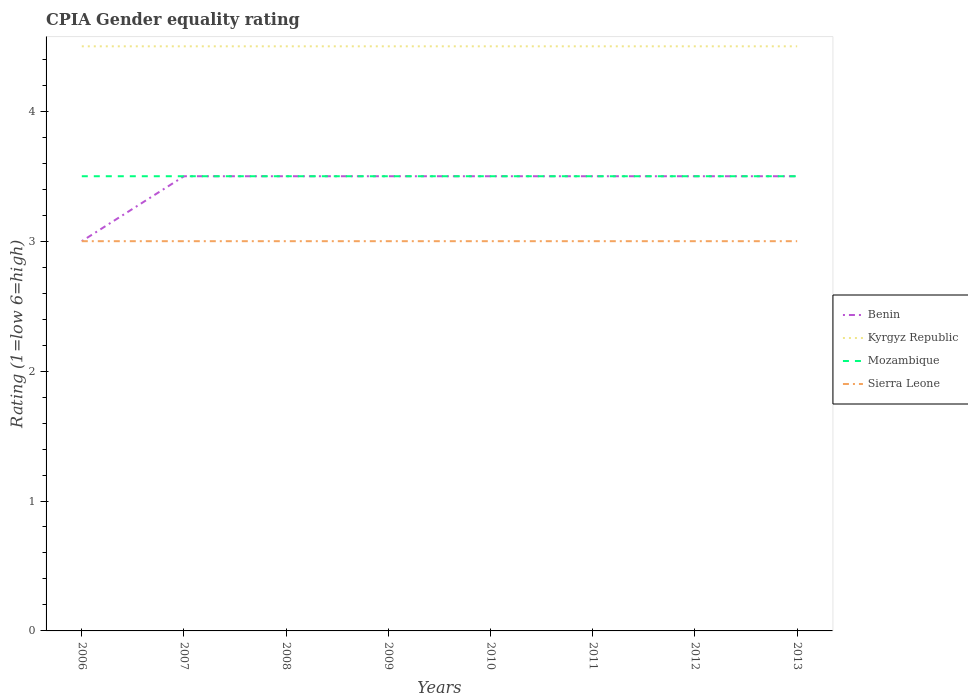Across all years, what is the maximum CPIA rating in Benin?
Ensure brevity in your answer.  3. In which year was the CPIA rating in Kyrgyz Republic maximum?
Offer a very short reply. 2006. What is the difference between the highest and the second highest CPIA rating in Kyrgyz Republic?
Provide a succinct answer. 0. What is the difference between the highest and the lowest CPIA rating in Benin?
Keep it short and to the point. 7. How many years are there in the graph?
Offer a terse response. 8. What is the difference between two consecutive major ticks on the Y-axis?
Provide a short and direct response. 1. How many legend labels are there?
Ensure brevity in your answer.  4. How are the legend labels stacked?
Ensure brevity in your answer.  Vertical. What is the title of the graph?
Provide a succinct answer. CPIA Gender equality rating. What is the label or title of the X-axis?
Your answer should be compact. Years. What is the Rating (1=low 6=high) in Benin in 2006?
Your response must be concise. 3. What is the Rating (1=low 6=high) of Sierra Leone in 2006?
Your answer should be very brief. 3. What is the Rating (1=low 6=high) in Kyrgyz Republic in 2007?
Provide a succinct answer. 4.5. What is the Rating (1=low 6=high) in Benin in 2008?
Your answer should be compact. 3.5. What is the Rating (1=low 6=high) of Benin in 2009?
Your answer should be very brief. 3.5. What is the Rating (1=low 6=high) of Kyrgyz Republic in 2009?
Give a very brief answer. 4.5. What is the Rating (1=low 6=high) in Benin in 2010?
Provide a succinct answer. 3.5. What is the Rating (1=low 6=high) of Mozambique in 2011?
Provide a succinct answer. 3.5. What is the Rating (1=low 6=high) in Sierra Leone in 2011?
Give a very brief answer. 3. What is the Rating (1=low 6=high) in Kyrgyz Republic in 2012?
Keep it short and to the point. 4.5. What is the Rating (1=low 6=high) of Kyrgyz Republic in 2013?
Your answer should be compact. 4.5. What is the Rating (1=low 6=high) in Mozambique in 2013?
Provide a succinct answer. 3.5. Across all years, what is the maximum Rating (1=low 6=high) of Benin?
Offer a terse response. 3.5. Across all years, what is the maximum Rating (1=low 6=high) in Kyrgyz Republic?
Your answer should be very brief. 4.5. Across all years, what is the maximum Rating (1=low 6=high) of Sierra Leone?
Provide a short and direct response. 3. Across all years, what is the minimum Rating (1=low 6=high) in Benin?
Your response must be concise. 3. Across all years, what is the minimum Rating (1=low 6=high) of Kyrgyz Republic?
Ensure brevity in your answer.  4.5. Across all years, what is the minimum Rating (1=low 6=high) in Sierra Leone?
Your answer should be compact. 3. What is the total Rating (1=low 6=high) of Kyrgyz Republic in the graph?
Provide a succinct answer. 36. What is the difference between the Rating (1=low 6=high) of Benin in 2006 and that in 2008?
Provide a short and direct response. -0.5. What is the difference between the Rating (1=low 6=high) of Sierra Leone in 2006 and that in 2008?
Provide a short and direct response. 0. What is the difference between the Rating (1=low 6=high) in Mozambique in 2006 and that in 2009?
Provide a short and direct response. 0. What is the difference between the Rating (1=low 6=high) in Benin in 2006 and that in 2010?
Provide a succinct answer. -0.5. What is the difference between the Rating (1=low 6=high) of Kyrgyz Republic in 2006 and that in 2010?
Provide a short and direct response. 0. What is the difference between the Rating (1=low 6=high) in Mozambique in 2006 and that in 2010?
Your response must be concise. 0. What is the difference between the Rating (1=low 6=high) of Sierra Leone in 2006 and that in 2010?
Keep it short and to the point. 0. What is the difference between the Rating (1=low 6=high) in Kyrgyz Republic in 2006 and that in 2011?
Ensure brevity in your answer.  0. What is the difference between the Rating (1=low 6=high) of Sierra Leone in 2006 and that in 2011?
Ensure brevity in your answer.  0. What is the difference between the Rating (1=low 6=high) in Benin in 2006 and that in 2012?
Make the answer very short. -0.5. What is the difference between the Rating (1=low 6=high) of Mozambique in 2006 and that in 2012?
Offer a very short reply. 0. What is the difference between the Rating (1=low 6=high) of Sierra Leone in 2006 and that in 2012?
Offer a terse response. 0. What is the difference between the Rating (1=low 6=high) of Sierra Leone in 2007 and that in 2008?
Make the answer very short. 0. What is the difference between the Rating (1=low 6=high) of Mozambique in 2007 and that in 2009?
Your response must be concise. 0. What is the difference between the Rating (1=low 6=high) in Sierra Leone in 2007 and that in 2009?
Give a very brief answer. 0. What is the difference between the Rating (1=low 6=high) in Benin in 2007 and that in 2010?
Provide a succinct answer. 0. What is the difference between the Rating (1=low 6=high) of Mozambique in 2007 and that in 2010?
Make the answer very short. 0. What is the difference between the Rating (1=low 6=high) in Sierra Leone in 2007 and that in 2010?
Keep it short and to the point. 0. What is the difference between the Rating (1=low 6=high) of Benin in 2007 and that in 2012?
Keep it short and to the point. 0. What is the difference between the Rating (1=low 6=high) of Mozambique in 2007 and that in 2012?
Provide a short and direct response. 0. What is the difference between the Rating (1=low 6=high) in Benin in 2007 and that in 2013?
Provide a succinct answer. 0. What is the difference between the Rating (1=low 6=high) in Mozambique in 2007 and that in 2013?
Make the answer very short. 0. What is the difference between the Rating (1=low 6=high) in Sierra Leone in 2007 and that in 2013?
Offer a very short reply. 0. What is the difference between the Rating (1=low 6=high) of Benin in 2008 and that in 2009?
Provide a short and direct response. 0. What is the difference between the Rating (1=low 6=high) in Kyrgyz Republic in 2008 and that in 2009?
Offer a very short reply. 0. What is the difference between the Rating (1=low 6=high) of Sierra Leone in 2008 and that in 2010?
Your answer should be very brief. 0. What is the difference between the Rating (1=low 6=high) of Benin in 2008 and that in 2011?
Your answer should be compact. 0. What is the difference between the Rating (1=low 6=high) in Mozambique in 2008 and that in 2011?
Ensure brevity in your answer.  0. What is the difference between the Rating (1=low 6=high) in Benin in 2008 and that in 2012?
Give a very brief answer. 0. What is the difference between the Rating (1=low 6=high) in Mozambique in 2008 and that in 2012?
Keep it short and to the point. 0. What is the difference between the Rating (1=low 6=high) in Benin in 2008 and that in 2013?
Ensure brevity in your answer.  0. What is the difference between the Rating (1=low 6=high) of Sierra Leone in 2008 and that in 2013?
Give a very brief answer. 0. What is the difference between the Rating (1=low 6=high) in Benin in 2009 and that in 2010?
Keep it short and to the point. 0. What is the difference between the Rating (1=low 6=high) of Kyrgyz Republic in 2009 and that in 2010?
Provide a succinct answer. 0. What is the difference between the Rating (1=low 6=high) of Kyrgyz Republic in 2009 and that in 2011?
Offer a very short reply. 0. What is the difference between the Rating (1=low 6=high) in Mozambique in 2009 and that in 2011?
Offer a terse response. 0. What is the difference between the Rating (1=low 6=high) in Sierra Leone in 2009 and that in 2011?
Make the answer very short. 0. What is the difference between the Rating (1=low 6=high) in Benin in 2009 and that in 2012?
Ensure brevity in your answer.  0. What is the difference between the Rating (1=low 6=high) in Kyrgyz Republic in 2009 and that in 2012?
Provide a short and direct response. 0. What is the difference between the Rating (1=low 6=high) in Sierra Leone in 2009 and that in 2012?
Offer a terse response. 0. What is the difference between the Rating (1=low 6=high) of Sierra Leone in 2009 and that in 2013?
Your answer should be compact. 0. What is the difference between the Rating (1=low 6=high) of Benin in 2010 and that in 2011?
Your answer should be compact. 0. What is the difference between the Rating (1=low 6=high) of Sierra Leone in 2010 and that in 2011?
Your answer should be compact. 0. What is the difference between the Rating (1=low 6=high) in Benin in 2010 and that in 2012?
Your answer should be compact. 0. What is the difference between the Rating (1=low 6=high) in Kyrgyz Republic in 2010 and that in 2012?
Keep it short and to the point. 0. What is the difference between the Rating (1=low 6=high) in Mozambique in 2010 and that in 2013?
Keep it short and to the point. 0. What is the difference between the Rating (1=low 6=high) of Benin in 2011 and that in 2012?
Offer a terse response. 0. What is the difference between the Rating (1=low 6=high) of Mozambique in 2011 and that in 2013?
Offer a very short reply. 0. What is the difference between the Rating (1=low 6=high) in Kyrgyz Republic in 2012 and that in 2013?
Make the answer very short. 0. What is the difference between the Rating (1=low 6=high) in Benin in 2006 and the Rating (1=low 6=high) in Sierra Leone in 2007?
Provide a short and direct response. 0. What is the difference between the Rating (1=low 6=high) in Kyrgyz Republic in 2006 and the Rating (1=low 6=high) in Mozambique in 2007?
Your response must be concise. 1. What is the difference between the Rating (1=low 6=high) of Benin in 2006 and the Rating (1=low 6=high) of Mozambique in 2008?
Make the answer very short. -0.5. What is the difference between the Rating (1=low 6=high) of Benin in 2006 and the Rating (1=low 6=high) of Mozambique in 2009?
Ensure brevity in your answer.  -0.5. What is the difference between the Rating (1=low 6=high) of Kyrgyz Republic in 2006 and the Rating (1=low 6=high) of Mozambique in 2009?
Keep it short and to the point. 1. What is the difference between the Rating (1=low 6=high) in Kyrgyz Republic in 2006 and the Rating (1=low 6=high) in Sierra Leone in 2009?
Give a very brief answer. 1.5. What is the difference between the Rating (1=low 6=high) in Mozambique in 2006 and the Rating (1=low 6=high) in Sierra Leone in 2009?
Your response must be concise. 0.5. What is the difference between the Rating (1=low 6=high) in Benin in 2006 and the Rating (1=low 6=high) in Sierra Leone in 2010?
Offer a very short reply. 0. What is the difference between the Rating (1=low 6=high) of Benin in 2006 and the Rating (1=low 6=high) of Mozambique in 2011?
Your response must be concise. -0.5. What is the difference between the Rating (1=low 6=high) of Benin in 2006 and the Rating (1=low 6=high) of Sierra Leone in 2011?
Your answer should be very brief. 0. What is the difference between the Rating (1=low 6=high) in Kyrgyz Republic in 2006 and the Rating (1=low 6=high) in Mozambique in 2011?
Make the answer very short. 1. What is the difference between the Rating (1=low 6=high) in Kyrgyz Republic in 2006 and the Rating (1=low 6=high) in Sierra Leone in 2011?
Keep it short and to the point. 1.5. What is the difference between the Rating (1=low 6=high) of Benin in 2006 and the Rating (1=low 6=high) of Mozambique in 2012?
Your answer should be compact. -0.5. What is the difference between the Rating (1=low 6=high) of Mozambique in 2006 and the Rating (1=low 6=high) of Sierra Leone in 2013?
Your answer should be very brief. 0.5. What is the difference between the Rating (1=low 6=high) of Benin in 2007 and the Rating (1=low 6=high) of Kyrgyz Republic in 2008?
Your answer should be compact. -1. What is the difference between the Rating (1=low 6=high) in Benin in 2007 and the Rating (1=low 6=high) in Sierra Leone in 2008?
Make the answer very short. 0.5. What is the difference between the Rating (1=low 6=high) in Kyrgyz Republic in 2007 and the Rating (1=low 6=high) in Sierra Leone in 2008?
Make the answer very short. 1.5. What is the difference between the Rating (1=low 6=high) of Benin in 2007 and the Rating (1=low 6=high) of Kyrgyz Republic in 2009?
Give a very brief answer. -1. What is the difference between the Rating (1=low 6=high) of Benin in 2007 and the Rating (1=low 6=high) of Sierra Leone in 2009?
Offer a terse response. 0.5. What is the difference between the Rating (1=low 6=high) in Kyrgyz Republic in 2007 and the Rating (1=low 6=high) in Mozambique in 2009?
Provide a short and direct response. 1. What is the difference between the Rating (1=low 6=high) of Mozambique in 2007 and the Rating (1=low 6=high) of Sierra Leone in 2010?
Your response must be concise. 0.5. What is the difference between the Rating (1=low 6=high) of Benin in 2007 and the Rating (1=low 6=high) of Mozambique in 2011?
Your answer should be very brief. 0. What is the difference between the Rating (1=low 6=high) of Kyrgyz Republic in 2007 and the Rating (1=low 6=high) of Mozambique in 2011?
Provide a succinct answer. 1. What is the difference between the Rating (1=low 6=high) of Kyrgyz Republic in 2007 and the Rating (1=low 6=high) of Sierra Leone in 2011?
Your answer should be very brief. 1.5. What is the difference between the Rating (1=low 6=high) of Benin in 2007 and the Rating (1=low 6=high) of Mozambique in 2012?
Provide a short and direct response. 0. What is the difference between the Rating (1=low 6=high) of Kyrgyz Republic in 2007 and the Rating (1=low 6=high) of Sierra Leone in 2013?
Provide a succinct answer. 1.5. What is the difference between the Rating (1=low 6=high) in Mozambique in 2007 and the Rating (1=low 6=high) in Sierra Leone in 2013?
Your response must be concise. 0.5. What is the difference between the Rating (1=low 6=high) in Benin in 2008 and the Rating (1=low 6=high) in Kyrgyz Republic in 2009?
Keep it short and to the point. -1. What is the difference between the Rating (1=low 6=high) of Benin in 2008 and the Rating (1=low 6=high) of Sierra Leone in 2009?
Ensure brevity in your answer.  0.5. What is the difference between the Rating (1=low 6=high) in Kyrgyz Republic in 2008 and the Rating (1=low 6=high) in Mozambique in 2009?
Keep it short and to the point. 1. What is the difference between the Rating (1=low 6=high) in Kyrgyz Republic in 2008 and the Rating (1=low 6=high) in Sierra Leone in 2009?
Keep it short and to the point. 1.5. What is the difference between the Rating (1=low 6=high) of Benin in 2008 and the Rating (1=low 6=high) of Kyrgyz Republic in 2010?
Make the answer very short. -1. What is the difference between the Rating (1=low 6=high) of Benin in 2008 and the Rating (1=low 6=high) of Mozambique in 2010?
Offer a very short reply. 0. What is the difference between the Rating (1=low 6=high) in Kyrgyz Republic in 2008 and the Rating (1=low 6=high) in Sierra Leone in 2010?
Your answer should be compact. 1.5. What is the difference between the Rating (1=low 6=high) of Mozambique in 2008 and the Rating (1=low 6=high) of Sierra Leone in 2010?
Your answer should be very brief. 0.5. What is the difference between the Rating (1=low 6=high) of Benin in 2008 and the Rating (1=low 6=high) of Mozambique in 2011?
Offer a very short reply. 0. What is the difference between the Rating (1=low 6=high) of Benin in 2008 and the Rating (1=low 6=high) of Sierra Leone in 2011?
Your answer should be compact. 0.5. What is the difference between the Rating (1=low 6=high) in Kyrgyz Republic in 2008 and the Rating (1=low 6=high) in Sierra Leone in 2011?
Give a very brief answer. 1.5. What is the difference between the Rating (1=low 6=high) of Benin in 2008 and the Rating (1=low 6=high) of Kyrgyz Republic in 2012?
Provide a succinct answer. -1. What is the difference between the Rating (1=low 6=high) of Benin in 2008 and the Rating (1=low 6=high) of Mozambique in 2012?
Your response must be concise. 0. What is the difference between the Rating (1=low 6=high) of Kyrgyz Republic in 2008 and the Rating (1=low 6=high) of Mozambique in 2012?
Provide a short and direct response. 1. What is the difference between the Rating (1=low 6=high) in Kyrgyz Republic in 2008 and the Rating (1=low 6=high) in Sierra Leone in 2012?
Your answer should be compact. 1.5. What is the difference between the Rating (1=low 6=high) of Benin in 2008 and the Rating (1=low 6=high) of Mozambique in 2013?
Give a very brief answer. 0. What is the difference between the Rating (1=low 6=high) in Kyrgyz Republic in 2008 and the Rating (1=low 6=high) in Mozambique in 2013?
Your answer should be very brief. 1. What is the difference between the Rating (1=low 6=high) in Benin in 2009 and the Rating (1=low 6=high) in Mozambique in 2010?
Ensure brevity in your answer.  0. What is the difference between the Rating (1=low 6=high) in Benin in 2009 and the Rating (1=low 6=high) in Sierra Leone in 2010?
Ensure brevity in your answer.  0.5. What is the difference between the Rating (1=low 6=high) in Kyrgyz Republic in 2009 and the Rating (1=low 6=high) in Mozambique in 2010?
Give a very brief answer. 1. What is the difference between the Rating (1=low 6=high) of Kyrgyz Republic in 2009 and the Rating (1=low 6=high) of Mozambique in 2011?
Provide a short and direct response. 1. What is the difference between the Rating (1=low 6=high) in Kyrgyz Republic in 2009 and the Rating (1=low 6=high) in Sierra Leone in 2011?
Provide a short and direct response. 1.5. What is the difference between the Rating (1=low 6=high) of Mozambique in 2009 and the Rating (1=low 6=high) of Sierra Leone in 2011?
Your answer should be compact. 0.5. What is the difference between the Rating (1=low 6=high) in Benin in 2009 and the Rating (1=low 6=high) in Kyrgyz Republic in 2012?
Give a very brief answer. -1. What is the difference between the Rating (1=low 6=high) of Benin in 2009 and the Rating (1=low 6=high) of Mozambique in 2012?
Offer a terse response. 0. What is the difference between the Rating (1=low 6=high) of Kyrgyz Republic in 2009 and the Rating (1=low 6=high) of Mozambique in 2012?
Provide a short and direct response. 1. What is the difference between the Rating (1=low 6=high) in Benin in 2009 and the Rating (1=low 6=high) in Mozambique in 2013?
Make the answer very short. 0. What is the difference between the Rating (1=low 6=high) of Kyrgyz Republic in 2009 and the Rating (1=low 6=high) of Mozambique in 2013?
Provide a succinct answer. 1. What is the difference between the Rating (1=low 6=high) in Mozambique in 2009 and the Rating (1=low 6=high) in Sierra Leone in 2013?
Your answer should be compact. 0.5. What is the difference between the Rating (1=low 6=high) of Benin in 2010 and the Rating (1=low 6=high) of Kyrgyz Republic in 2011?
Make the answer very short. -1. What is the difference between the Rating (1=low 6=high) of Benin in 2010 and the Rating (1=low 6=high) of Sierra Leone in 2011?
Make the answer very short. 0.5. What is the difference between the Rating (1=low 6=high) of Kyrgyz Republic in 2010 and the Rating (1=low 6=high) of Sierra Leone in 2011?
Give a very brief answer. 1.5. What is the difference between the Rating (1=low 6=high) in Benin in 2010 and the Rating (1=low 6=high) in Kyrgyz Republic in 2012?
Your response must be concise. -1. What is the difference between the Rating (1=low 6=high) of Kyrgyz Republic in 2010 and the Rating (1=low 6=high) of Sierra Leone in 2012?
Your answer should be very brief. 1.5. What is the difference between the Rating (1=low 6=high) of Mozambique in 2010 and the Rating (1=low 6=high) of Sierra Leone in 2012?
Ensure brevity in your answer.  0.5. What is the difference between the Rating (1=low 6=high) in Benin in 2010 and the Rating (1=low 6=high) in Sierra Leone in 2013?
Provide a short and direct response. 0.5. What is the difference between the Rating (1=low 6=high) of Mozambique in 2010 and the Rating (1=low 6=high) of Sierra Leone in 2013?
Give a very brief answer. 0.5. What is the difference between the Rating (1=low 6=high) in Benin in 2011 and the Rating (1=low 6=high) in Kyrgyz Republic in 2012?
Provide a succinct answer. -1. What is the difference between the Rating (1=low 6=high) in Benin in 2011 and the Rating (1=low 6=high) in Mozambique in 2012?
Your answer should be very brief. 0. What is the difference between the Rating (1=low 6=high) of Kyrgyz Republic in 2011 and the Rating (1=low 6=high) of Mozambique in 2012?
Your answer should be compact. 1. What is the difference between the Rating (1=low 6=high) of Mozambique in 2011 and the Rating (1=low 6=high) of Sierra Leone in 2012?
Your response must be concise. 0.5. What is the difference between the Rating (1=low 6=high) in Benin in 2011 and the Rating (1=low 6=high) in Mozambique in 2013?
Your answer should be very brief. 0. What is the difference between the Rating (1=low 6=high) in Mozambique in 2011 and the Rating (1=low 6=high) in Sierra Leone in 2013?
Keep it short and to the point. 0.5. What is the difference between the Rating (1=low 6=high) of Benin in 2012 and the Rating (1=low 6=high) of Kyrgyz Republic in 2013?
Your response must be concise. -1. What is the difference between the Rating (1=low 6=high) of Benin in 2012 and the Rating (1=low 6=high) of Mozambique in 2013?
Your response must be concise. 0. What is the difference between the Rating (1=low 6=high) in Kyrgyz Republic in 2012 and the Rating (1=low 6=high) in Sierra Leone in 2013?
Make the answer very short. 1.5. What is the average Rating (1=low 6=high) of Benin per year?
Provide a succinct answer. 3.44. What is the average Rating (1=low 6=high) in Kyrgyz Republic per year?
Offer a terse response. 4.5. In the year 2006, what is the difference between the Rating (1=low 6=high) of Benin and Rating (1=low 6=high) of Kyrgyz Republic?
Your answer should be compact. -1.5. In the year 2006, what is the difference between the Rating (1=low 6=high) in Benin and Rating (1=low 6=high) in Sierra Leone?
Your answer should be very brief. 0. In the year 2006, what is the difference between the Rating (1=low 6=high) in Mozambique and Rating (1=low 6=high) in Sierra Leone?
Keep it short and to the point. 0.5. In the year 2007, what is the difference between the Rating (1=low 6=high) of Benin and Rating (1=low 6=high) of Mozambique?
Provide a short and direct response. 0. In the year 2007, what is the difference between the Rating (1=low 6=high) of Benin and Rating (1=low 6=high) of Sierra Leone?
Keep it short and to the point. 0.5. In the year 2007, what is the difference between the Rating (1=low 6=high) of Kyrgyz Republic and Rating (1=low 6=high) of Sierra Leone?
Give a very brief answer. 1.5. In the year 2007, what is the difference between the Rating (1=low 6=high) of Mozambique and Rating (1=low 6=high) of Sierra Leone?
Your answer should be very brief. 0.5. In the year 2008, what is the difference between the Rating (1=low 6=high) of Benin and Rating (1=low 6=high) of Mozambique?
Your answer should be very brief. 0. In the year 2008, what is the difference between the Rating (1=low 6=high) of Kyrgyz Republic and Rating (1=low 6=high) of Sierra Leone?
Offer a terse response. 1.5. In the year 2009, what is the difference between the Rating (1=low 6=high) of Benin and Rating (1=low 6=high) of Kyrgyz Republic?
Your response must be concise. -1. In the year 2009, what is the difference between the Rating (1=low 6=high) of Benin and Rating (1=low 6=high) of Mozambique?
Your answer should be very brief. 0. In the year 2009, what is the difference between the Rating (1=low 6=high) in Kyrgyz Republic and Rating (1=low 6=high) in Mozambique?
Your answer should be compact. 1. In the year 2009, what is the difference between the Rating (1=low 6=high) in Mozambique and Rating (1=low 6=high) in Sierra Leone?
Ensure brevity in your answer.  0.5. In the year 2010, what is the difference between the Rating (1=low 6=high) of Benin and Rating (1=low 6=high) of Sierra Leone?
Offer a terse response. 0.5. In the year 2010, what is the difference between the Rating (1=low 6=high) in Kyrgyz Republic and Rating (1=low 6=high) in Mozambique?
Provide a succinct answer. 1. In the year 2010, what is the difference between the Rating (1=low 6=high) in Mozambique and Rating (1=low 6=high) in Sierra Leone?
Offer a very short reply. 0.5. In the year 2011, what is the difference between the Rating (1=low 6=high) of Benin and Rating (1=low 6=high) of Mozambique?
Make the answer very short. 0. In the year 2011, what is the difference between the Rating (1=low 6=high) of Kyrgyz Republic and Rating (1=low 6=high) of Mozambique?
Keep it short and to the point. 1. In the year 2012, what is the difference between the Rating (1=low 6=high) in Benin and Rating (1=low 6=high) in Kyrgyz Republic?
Your response must be concise. -1. In the year 2012, what is the difference between the Rating (1=low 6=high) of Benin and Rating (1=low 6=high) of Mozambique?
Provide a succinct answer. 0. In the year 2012, what is the difference between the Rating (1=low 6=high) of Benin and Rating (1=low 6=high) of Sierra Leone?
Your answer should be compact. 0.5. In the year 2013, what is the difference between the Rating (1=low 6=high) of Kyrgyz Republic and Rating (1=low 6=high) of Sierra Leone?
Give a very brief answer. 1.5. In the year 2013, what is the difference between the Rating (1=low 6=high) of Mozambique and Rating (1=low 6=high) of Sierra Leone?
Keep it short and to the point. 0.5. What is the ratio of the Rating (1=low 6=high) in Benin in 2006 to that in 2007?
Provide a short and direct response. 0.86. What is the ratio of the Rating (1=low 6=high) in Kyrgyz Republic in 2006 to that in 2007?
Your answer should be very brief. 1. What is the ratio of the Rating (1=low 6=high) of Benin in 2006 to that in 2008?
Provide a short and direct response. 0.86. What is the ratio of the Rating (1=low 6=high) of Sierra Leone in 2006 to that in 2008?
Your answer should be very brief. 1. What is the ratio of the Rating (1=low 6=high) in Kyrgyz Republic in 2006 to that in 2009?
Offer a very short reply. 1. What is the ratio of the Rating (1=low 6=high) of Sierra Leone in 2006 to that in 2009?
Make the answer very short. 1. What is the ratio of the Rating (1=low 6=high) of Benin in 2006 to that in 2010?
Make the answer very short. 0.86. What is the ratio of the Rating (1=low 6=high) in Kyrgyz Republic in 2006 to that in 2010?
Offer a terse response. 1. What is the ratio of the Rating (1=low 6=high) in Sierra Leone in 2006 to that in 2010?
Your answer should be compact. 1. What is the ratio of the Rating (1=low 6=high) in Kyrgyz Republic in 2006 to that in 2011?
Make the answer very short. 1. What is the ratio of the Rating (1=low 6=high) in Sierra Leone in 2006 to that in 2011?
Your response must be concise. 1. What is the ratio of the Rating (1=low 6=high) in Benin in 2006 to that in 2012?
Provide a short and direct response. 0.86. What is the ratio of the Rating (1=low 6=high) of Kyrgyz Republic in 2006 to that in 2012?
Offer a very short reply. 1. What is the ratio of the Rating (1=low 6=high) in Mozambique in 2006 to that in 2012?
Keep it short and to the point. 1. What is the ratio of the Rating (1=low 6=high) in Sierra Leone in 2006 to that in 2012?
Your answer should be compact. 1. What is the ratio of the Rating (1=low 6=high) in Kyrgyz Republic in 2006 to that in 2013?
Ensure brevity in your answer.  1. What is the ratio of the Rating (1=low 6=high) in Sierra Leone in 2006 to that in 2013?
Provide a succinct answer. 1. What is the ratio of the Rating (1=low 6=high) of Benin in 2007 to that in 2009?
Provide a succinct answer. 1. What is the ratio of the Rating (1=low 6=high) in Kyrgyz Republic in 2007 to that in 2009?
Make the answer very short. 1. What is the ratio of the Rating (1=low 6=high) of Benin in 2007 to that in 2010?
Your response must be concise. 1. What is the ratio of the Rating (1=low 6=high) in Mozambique in 2007 to that in 2010?
Your response must be concise. 1. What is the ratio of the Rating (1=low 6=high) of Mozambique in 2007 to that in 2011?
Keep it short and to the point. 1. What is the ratio of the Rating (1=low 6=high) in Sierra Leone in 2007 to that in 2011?
Give a very brief answer. 1. What is the ratio of the Rating (1=low 6=high) in Mozambique in 2007 to that in 2012?
Your answer should be very brief. 1. What is the ratio of the Rating (1=low 6=high) in Sierra Leone in 2007 to that in 2012?
Offer a very short reply. 1. What is the ratio of the Rating (1=low 6=high) in Kyrgyz Republic in 2007 to that in 2013?
Make the answer very short. 1. What is the ratio of the Rating (1=low 6=high) in Mozambique in 2007 to that in 2013?
Make the answer very short. 1. What is the ratio of the Rating (1=low 6=high) in Sierra Leone in 2007 to that in 2013?
Provide a short and direct response. 1. What is the ratio of the Rating (1=low 6=high) of Sierra Leone in 2008 to that in 2009?
Provide a succinct answer. 1. What is the ratio of the Rating (1=low 6=high) of Benin in 2008 to that in 2010?
Provide a short and direct response. 1. What is the ratio of the Rating (1=low 6=high) in Kyrgyz Republic in 2008 to that in 2010?
Ensure brevity in your answer.  1. What is the ratio of the Rating (1=low 6=high) of Mozambique in 2008 to that in 2010?
Provide a short and direct response. 1. What is the ratio of the Rating (1=low 6=high) of Kyrgyz Republic in 2008 to that in 2011?
Make the answer very short. 1. What is the ratio of the Rating (1=low 6=high) of Mozambique in 2008 to that in 2011?
Give a very brief answer. 1. What is the ratio of the Rating (1=low 6=high) of Benin in 2008 to that in 2012?
Provide a short and direct response. 1. What is the ratio of the Rating (1=low 6=high) in Kyrgyz Republic in 2008 to that in 2012?
Offer a terse response. 1. What is the ratio of the Rating (1=low 6=high) of Mozambique in 2008 to that in 2012?
Provide a succinct answer. 1. What is the ratio of the Rating (1=low 6=high) of Kyrgyz Republic in 2008 to that in 2013?
Provide a succinct answer. 1. What is the ratio of the Rating (1=low 6=high) in Mozambique in 2008 to that in 2013?
Provide a short and direct response. 1. What is the ratio of the Rating (1=low 6=high) of Sierra Leone in 2008 to that in 2013?
Offer a terse response. 1. What is the ratio of the Rating (1=low 6=high) of Benin in 2009 to that in 2010?
Your answer should be very brief. 1. What is the ratio of the Rating (1=low 6=high) in Sierra Leone in 2009 to that in 2010?
Provide a short and direct response. 1. What is the ratio of the Rating (1=low 6=high) in Benin in 2009 to that in 2011?
Provide a succinct answer. 1. What is the ratio of the Rating (1=low 6=high) of Kyrgyz Republic in 2009 to that in 2011?
Your response must be concise. 1. What is the ratio of the Rating (1=low 6=high) in Sierra Leone in 2009 to that in 2011?
Offer a terse response. 1. What is the ratio of the Rating (1=low 6=high) in Kyrgyz Republic in 2009 to that in 2012?
Your answer should be compact. 1. What is the ratio of the Rating (1=low 6=high) of Benin in 2009 to that in 2013?
Your answer should be very brief. 1. What is the ratio of the Rating (1=low 6=high) of Mozambique in 2009 to that in 2013?
Ensure brevity in your answer.  1. What is the ratio of the Rating (1=low 6=high) in Sierra Leone in 2009 to that in 2013?
Keep it short and to the point. 1. What is the ratio of the Rating (1=low 6=high) of Mozambique in 2010 to that in 2011?
Offer a terse response. 1. What is the ratio of the Rating (1=low 6=high) of Benin in 2010 to that in 2012?
Keep it short and to the point. 1. What is the ratio of the Rating (1=low 6=high) in Kyrgyz Republic in 2010 to that in 2012?
Make the answer very short. 1. What is the ratio of the Rating (1=low 6=high) in Sierra Leone in 2010 to that in 2012?
Make the answer very short. 1. What is the ratio of the Rating (1=low 6=high) in Kyrgyz Republic in 2010 to that in 2013?
Your answer should be very brief. 1. What is the ratio of the Rating (1=low 6=high) of Mozambique in 2010 to that in 2013?
Ensure brevity in your answer.  1. What is the ratio of the Rating (1=low 6=high) in Sierra Leone in 2010 to that in 2013?
Provide a short and direct response. 1. What is the ratio of the Rating (1=low 6=high) of Benin in 2011 to that in 2012?
Give a very brief answer. 1. What is the ratio of the Rating (1=low 6=high) of Mozambique in 2011 to that in 2012?
Your answer should be very brief. 1. What is the ratio of the Rating (1=low 6=high) in Mozambique in 2011 to that in 2013?
Your response must be concise. 1. What is the ratio of the Rating (1=low 6=high) of Sierra Leone in 2011 to that in 2013?
Offer a terse response. 1. What is the ratio of the Rating (1=low 6=high) of Benin in 2012 to that in 2013?
Keep it short and to the point. 1. What is the ratio of the Rating (1=low 6=high) of Kyrgyz Republic in 2012 to that in 2013?
Keep it short and to the point. 1. What is the ratio of the Rating (1=low 6=high) in Sierra Leone in 2012 to that in 2013?
Your answer should be compact. 1. What is the difference between the highest and the second highest Rating (1=low 6=high) in Benin?
Offer a terse response. 0. What is the difference between the highest and the second highest Rating (1=low 6=high) of Kyrgyz Republic?
Keep it short and to the point. 0. What is the difference between the highest and the second highest Rating (1=low 6=high) of Mozambique?
Your answer should be compact. 0. What is the difference between the highest and the lowest Rating (1=low 6=high) of Benin?
Offer a terse response. 0.5. What is the difference between the highest and the lowest Rating (1=low 6=high) of Mozambique?
Your answer should be very brief. 0. 